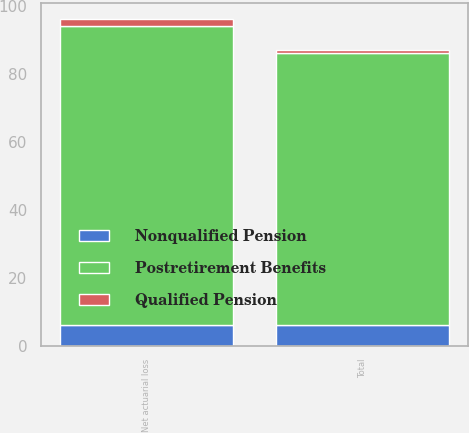<chart> <loc_0><loc_0><loc_500><loc_500><stacked_bar_chart><ecel><fcel>Net actuarial loss<fcel>Total<nl><fcel>Postretirement Benefits<fcel>88<fcel>80<nl><fcel>Nonqualified Pension<fcel>6<fcel>6<nl><fcel>Qualified Pension<fcel>2<fcel>1<nl></chart> 